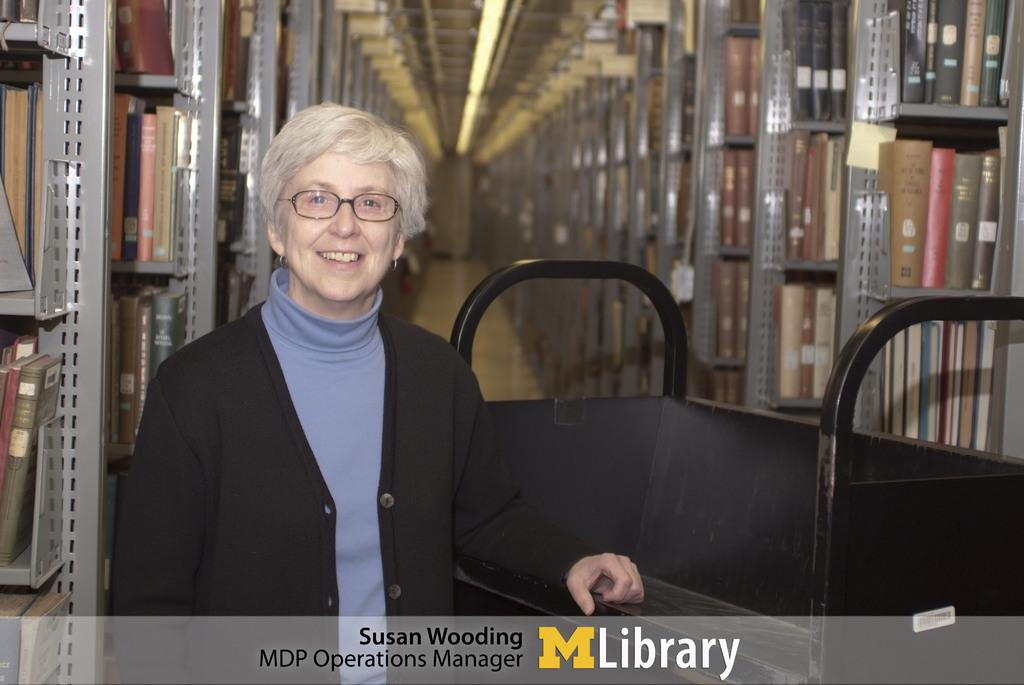What is the primary object in the front of the image? There is a black object in the front of the image. Who or what is also present in the front of the image? There is a person in the front of the image. What can be seen in the background of the image? There are racks, books, and lights in the background of the image. Is there any additional information about the image itself? Yes, there is a watermark at the bottom of the image. What type of music can be heard playing in the background of the image? There is no music present in the image; it only contains visual elements. What type of trousers is the person wearing in the image? The provided facts do not mention the person's clothing, so we cannot determine the type of trousers they are wearing. 